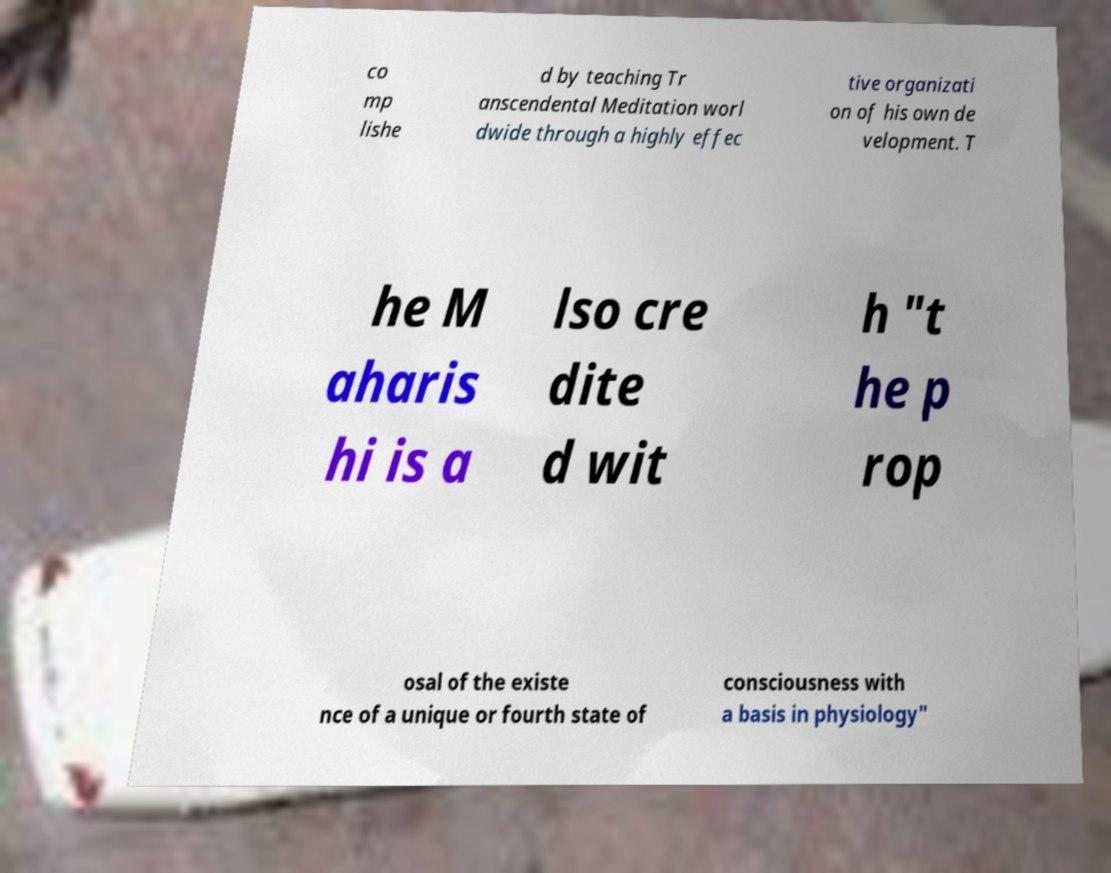Could you assist in decoding the text presented in this image and type it out clearly? co mp lishe d by teaching Tr anscendental Meditation worl dwide through a highly effec tive organizati on of his own de velopment. T he M aharis hi is a lso cre dite d wit h "t he p rop osal of the existe nce of a unique or fourth state of consciousness with a basis in physiology" 